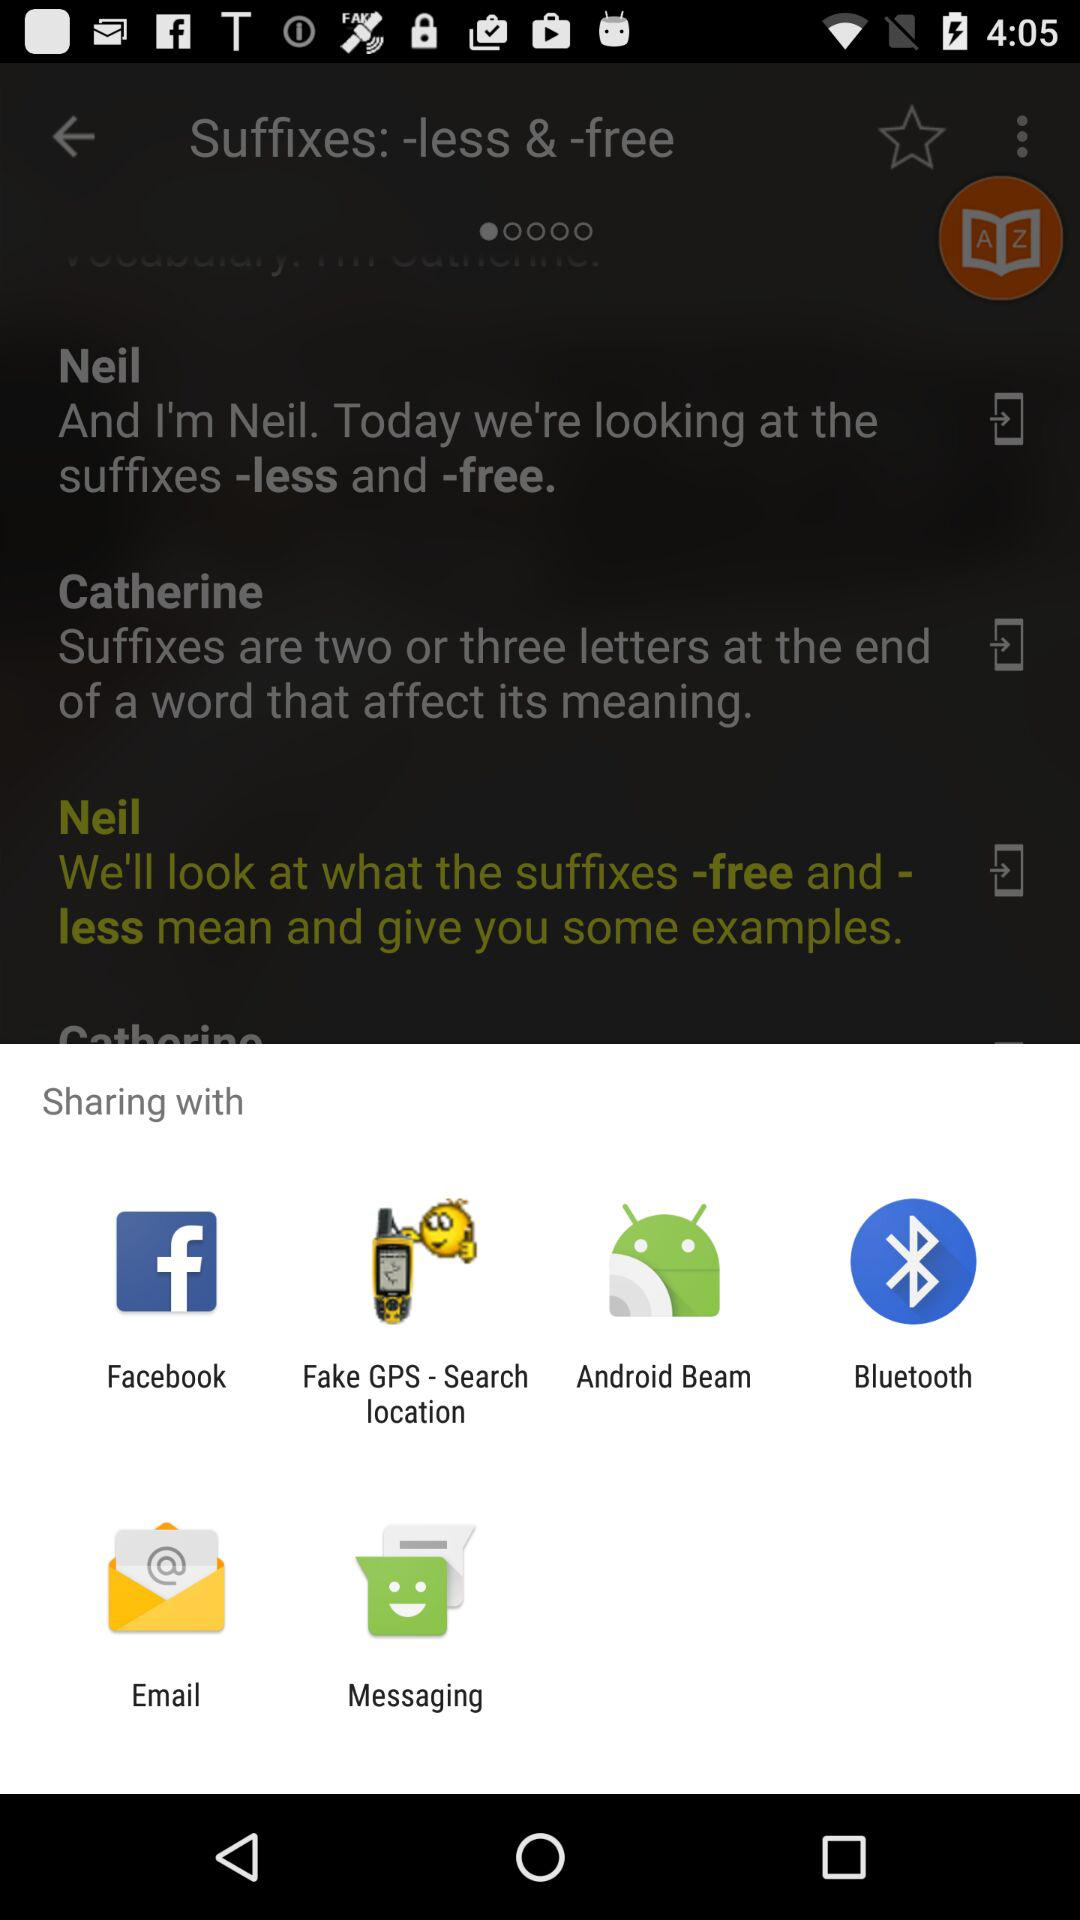Through which applications can we share? You can share through "Facebook", "Fake GPS - Search location", "Android Beam", "Bluetooth", "Email" and "Messaging". 